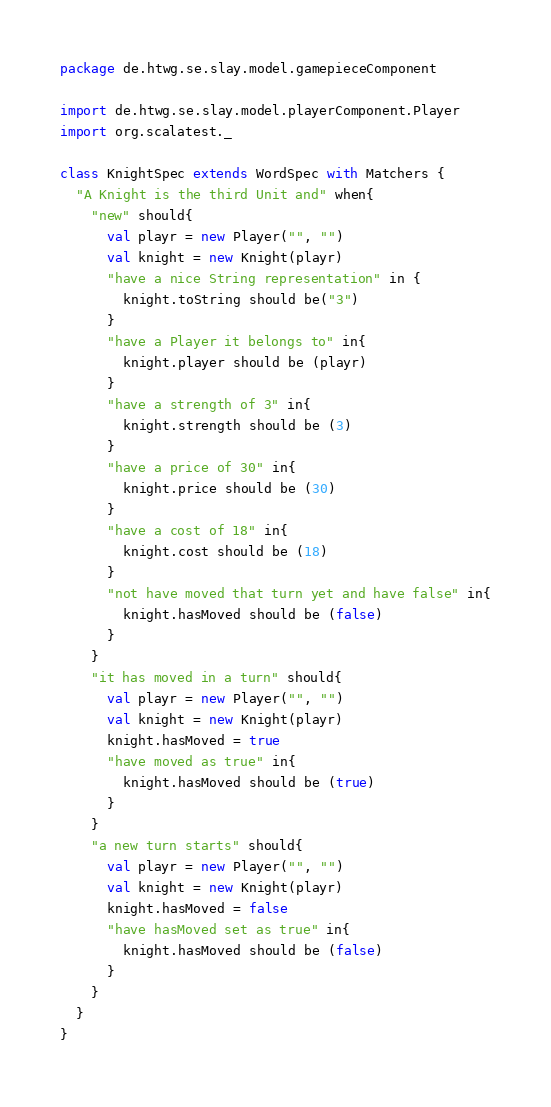Convert code to text. <code><loc_0><loc_0><loc_500><loc_500><_Scala_>package de.htwg.se.slay.model.gamepieceComponent

import de.htwg.se.slay.model.playerComponent.Player
import org.scalatest._

class KnightSpec extends WordSpec with Matchers {
  "A Knight is the third Unit and" when{
    "new" should{
      val playr = new Player("", "")
      val knight = new Knight(playr)
      "have a nice String representation" in {
        knight.toString should be("3")
      }
      "have a Player it belongs to" in{
        knight.player should be (playr)
      }
      "have a strength of 3" in{
        knight.strength should be (3)
      }
      "have a price of 30" in{
        knight.price should be (30)
      }
      "have a cost of 18" in{
        knight.cost should be (18)
      }
      "not have moved that turn yet and have false" in{
        knight.hasMoved should be (false)
      }
    }
    "it has moved in a turn" should{
      val playr = new Player("", "")
      val knight = new Knight(playr)
      knight.hasMoved = true
      "have moved as true" in{
        knight.hasMoved should be (true)
      }
    }
    "a new turn starts" should{
      val playr = new Player("", "")
      val knight = new Knight(playr)
      knight.hasMoved = false
      "have hasMoved set as true" in{
        knight.hasMoved should be (false)
      }
    }
  }
}
</code> 